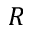Convert formula to latex. <formula><loc_0><loc_0><loc_500><loc_500>R</formula> 